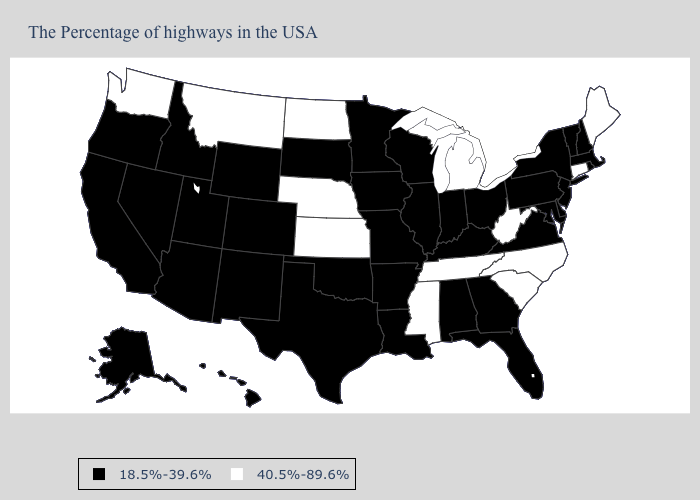What is the value of California?
Be succinct. 18.5%-39.6%. What is the lowest value in states that border Indiana?
Concise answer only. 18.5%-39.6%. Among the states that border Maryland , which have the lowest value?
Short answer required. Delaware, Pennsylvania, Virginia. Does Montana have the lowest value in the West?
Concise answer only. No. What is the value of New Mexico?
Write a very short answer. 18.5%-39.6%. Which states have the lowest value in the USA?
Quick response, please. Massachusetts, Rhode Island, New Hampshire, Vermont, New York, New Jersey, Delaware, Maryland, Pennsylvania, Virginia, Ohio, Florida, Georgia, Kentucky, Indiana, Alabama, Wisconsin, Illinois, Louisiana, Missouri, Arkansas, Minnesota, Iowa, Oklahoma, Texas, South Dakota, Wyoming, Colorado, New Mexico, Utah, Arizona, Idaho, Nevada, California, Oregon, Alaska, Hawaii. Does the map have missing data?
Concise answer only. No. Does the map have missing data?
Short answer required. No. Does the first symbol in the legend represent the smallest category?
Short answer required. Yes. Among the states that border Alabama , which have the highest value?
Answer briefly. Tennessee, Mississippi. Does the first symbol in the legend represent the smallest category?
Short answer required. Yes. Among the states that border Colorado , does Nebraska have the lowest value?
Give a very brief answer. No. Name the states that have a value in the range 18.5%-39.6%?
Write a very short answer. Massachusetts, Rhode Island, New Hampshire, Vermont, New York, New Jersey, Delaware, Maryland, Pennsylvania, Virginia, Ohio, Florida, Georgia, Kentucky, Indiana, Alabama, Wisconsin, Illinois, Louisiana, Missouri, Arkansas, Minnesota, Iowa, Oklahoma, Texas, South Dakota, Wyoming, Colorado, New Mexico, Utah, Arizona, Idaho, Nevada, California, Oregon, Alaska, Hawaii. Among the states that border North Carolina , does Georgia have the highest value?
Quick response, please. No. Name the states that have a value in the range 40.5%-89.6%?
Give a very brief answer. Maine, Connecticut, North Carolina, South Carolina, West Virginia, Michigan, Tennessee, Mississippi, Kansas, Nebraska, North Dakota, Montana, Washington. 